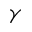<formula> <loc_0><loc_0><loc_500><loc_500>\gamma</formula> 